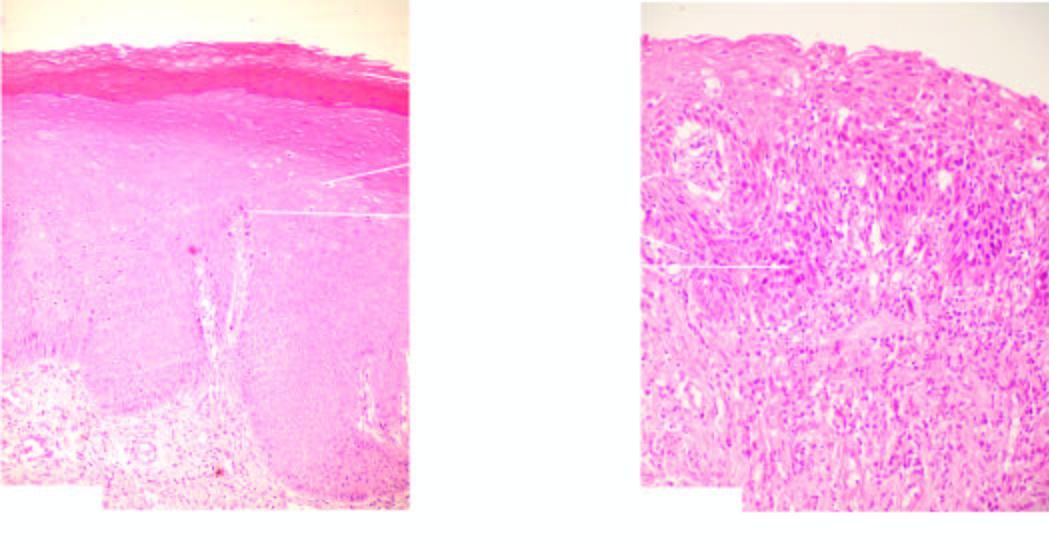what is increased?
Answer the question using a single word or phrase. Number of layers 